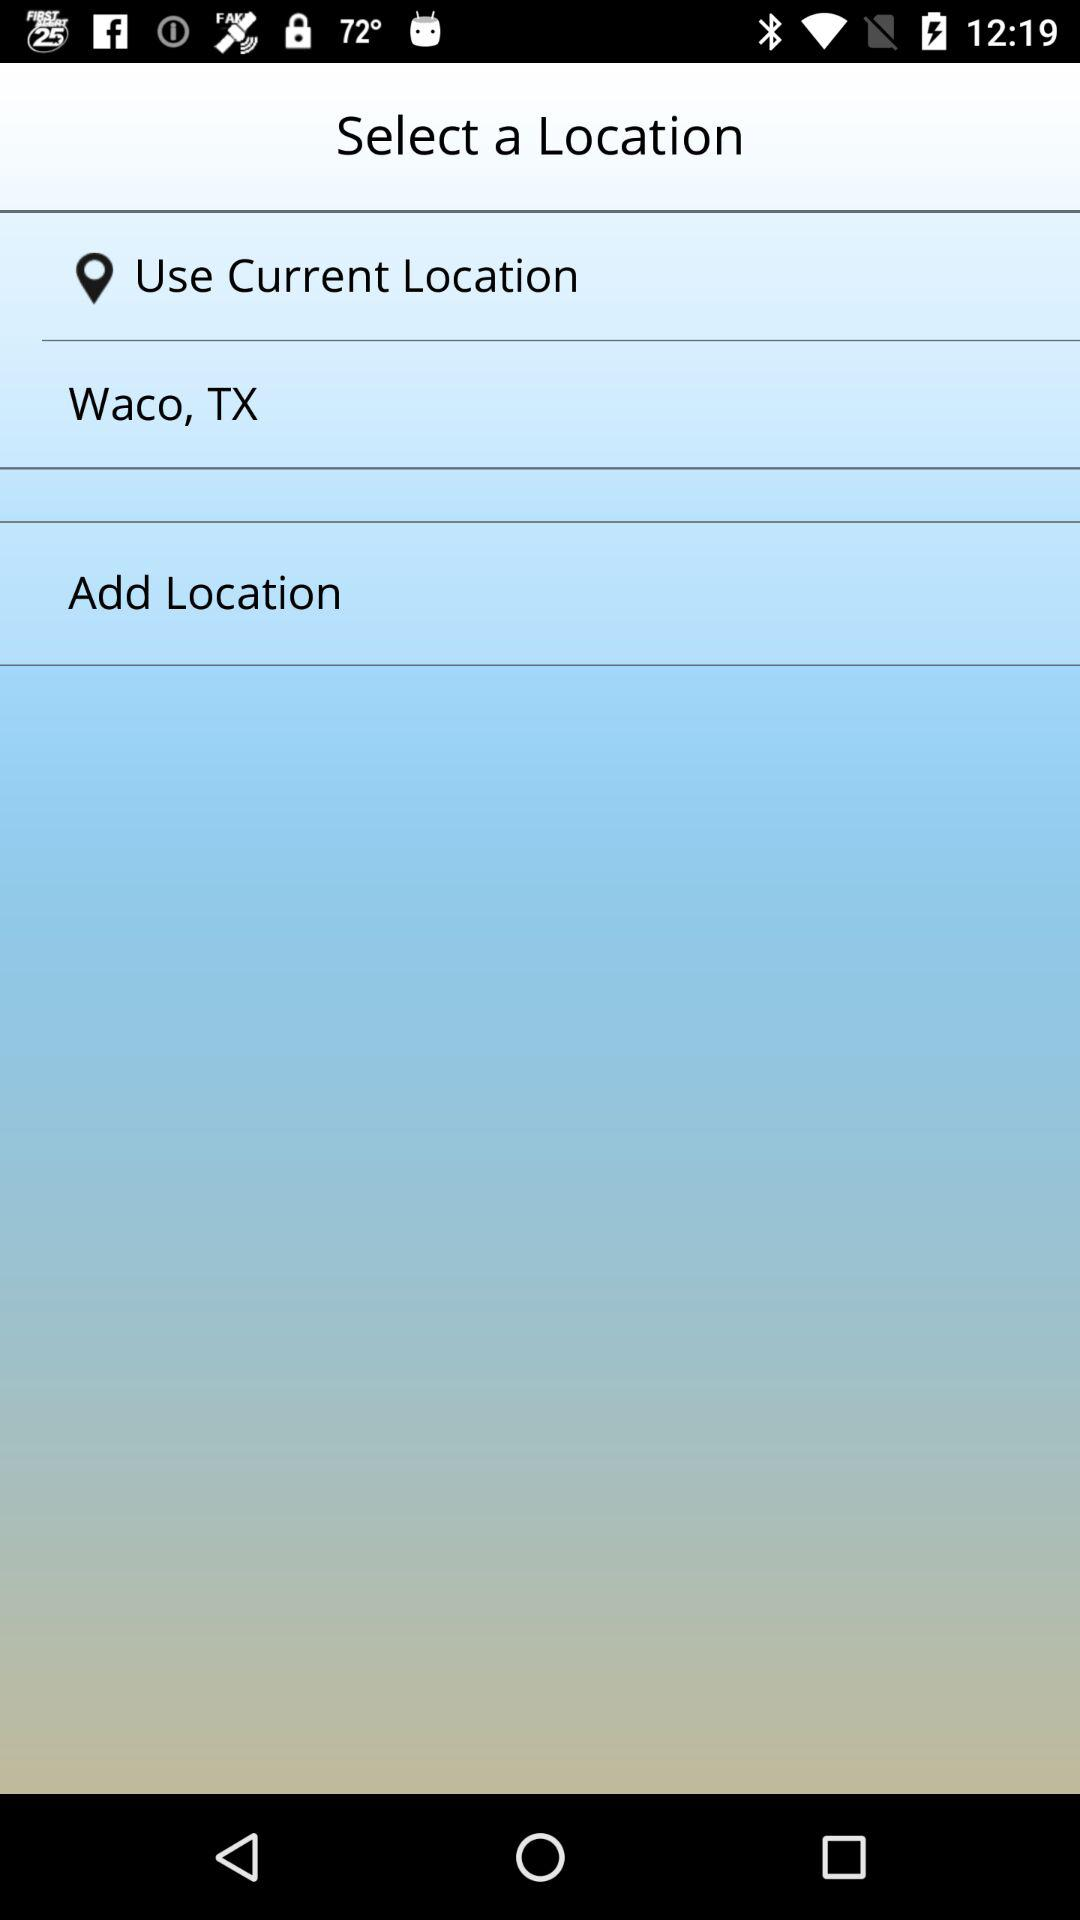When was the location selected?
When the provided information is insufficient, respond with <no answer>. <no answer> 